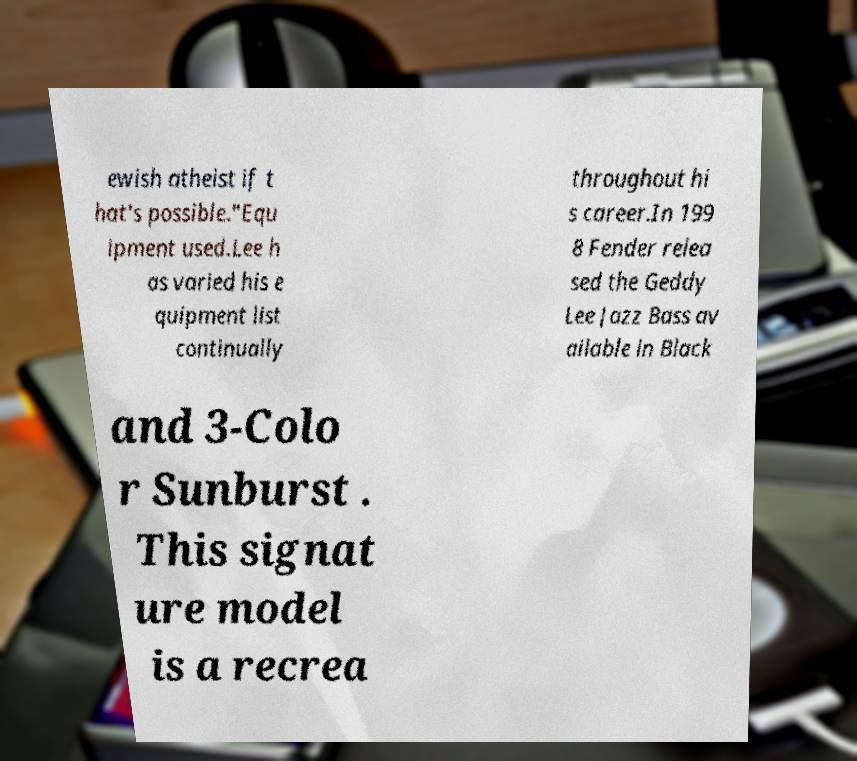What messages or text are displayed in this image? I need them in a readable, typed format. ewish atheist if t hat's possible."Equ ipment used.Lee h as varied his e quipment list continually throughout hi s career.In 199 8 Fender relea sed the Geddy Lee Jazz Bass av ailable in Black and 3-Colo r Sunburst . This signat ure model is a recrea 